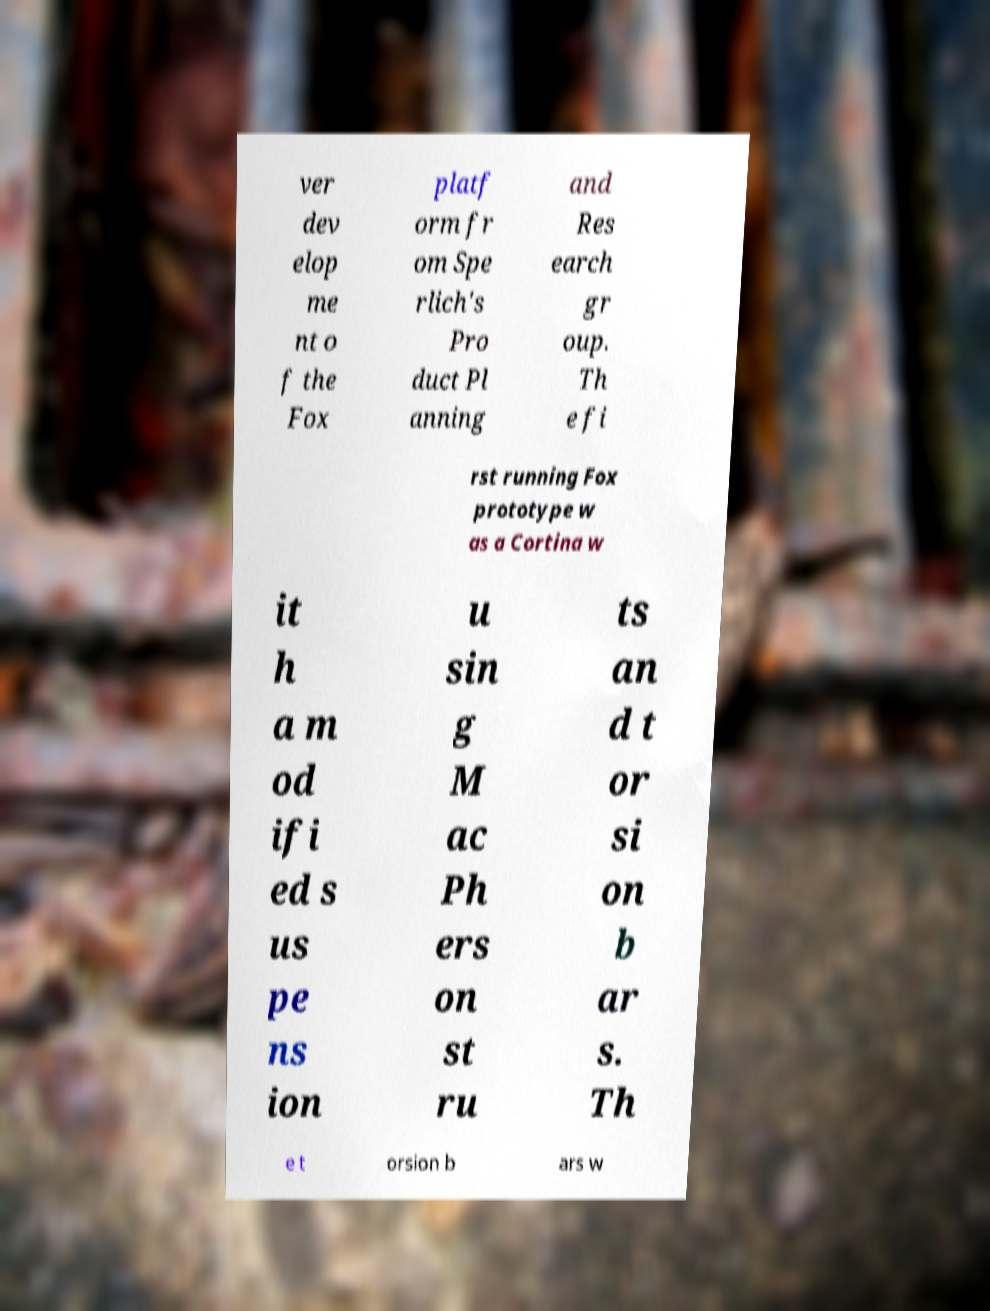Can you read and provide the text displayed in the image?This photo seems to have some interesting text. Can you extract and type it out for me? ver dev elop me nt o f the Fox platf orm fr om Spe rlich's Pro duct Pl anning and Res earch gr oup. Th e fi rst running Fox prototype w as a Cortina w it h a m od ifi ed s us pe ns ion u sin g M ac Ph ers on st ru ts an d t or si on b ar s. Th e t orsion b ars w 